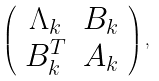Convert formula to latex. <formula><loc_0><loc_0><loc_500><loc_500>\left ( \begin{array} { c c } \Lambda _ { k } & B _ { k } \\ B _ { k } ^ { T } & A _ { k } \end{array} \right ) ,</formula> 